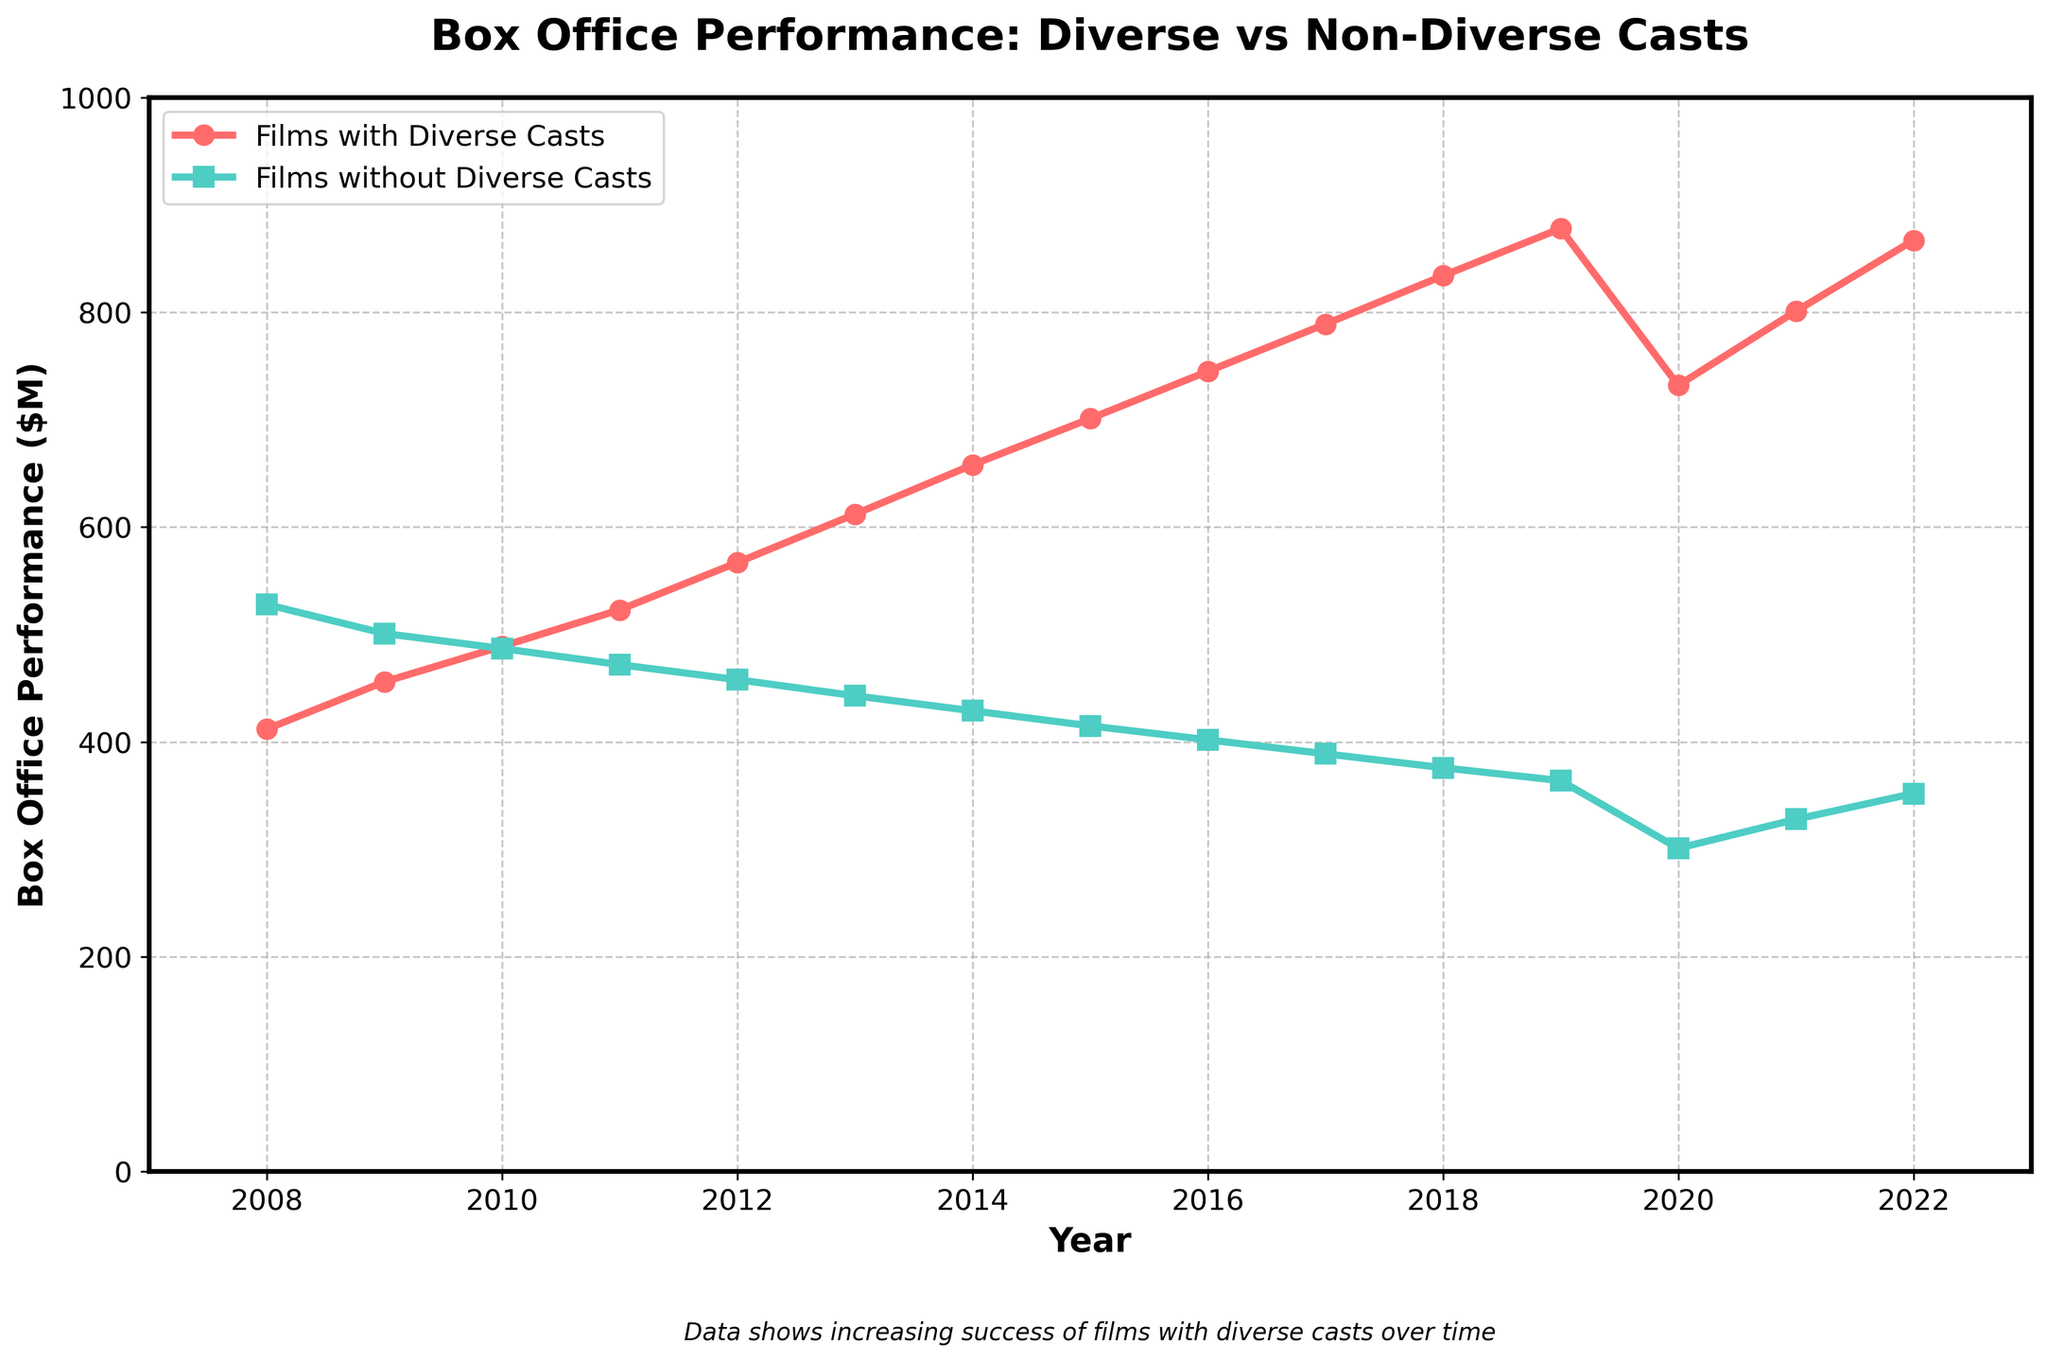What is the overall trend in box office performance for films with diverse casts over the last 15 years? The trend for films with diverse casts is consistently upward from 2008 to 2022, indicating an increase in box office performance each year.
Answer: Increasing How does the box office performance of films without diverse casts in 2019 compare to that in 2010? In 2010, the performance of films without diverse casts was $487 million, while in 2019, it was $364 million. This shows a decline over the years.
Answer: Declined Which year saw the highest box office performance for films with diverse casts? By examining the highest point of the red line, the year 2019 shows the highest box office performance at $878 million.
Answer: 2019 Calculate the average box office performance of films with diverse casts from 2010 to 2015. To find the average, sum the values from 2010 to 2015 and divide by the number of years: (489 + 523 + 567 + 612 + 658 + 701) / 6 = 550 million.
Answer: 550 million Between 2018 and 2020, which category of films (diverse or non-diverse casts) saw a greater drop in box office performance? Films with diverse casts dropped from $834 million in 2018 to $732 million in 2020, a decrease of 102 million. Films without diverse casts dropped from $376 million in 2018 to $301 million in 2020, a decrease of 75 million. Therefore, films with diverse casts saw a greater drop.
Answer: Diverse casts In what year do films with diverse casts first outperform films without diverse casts in terms of box office performance? Comparing the lines, films with diverse casts first outperform films without diverse casts in 2010.
Answer: 2010 What is the difference in box office performance between films with diverse casts and those without in 2021? Films with diverse casts earned $801 million, and those without earned $328 million in 2021. The difference is $801 million - $328 million = $473 million.
Answer: 473 million From 2009 to 2011, what is the percentage change in box office performance for films with diverse casts? The performance in 2009 was $456 million and in 2011 it was $523 million. The percentage change is [(523 - 456) / 456] * 100 = 14.69%.
Answer: 14.69% Calculate the median box office performance for films with diverse casts from 2008 to 2022. The ordered values are: 412, 456, 489, 523, 567, 612, 658, 701, 732, 745, 789, 801, 834, 867, 878. The median is the middle value, which is $701 million for the 8th position.
Answer: 701 million What is the visual difference in colors used to represent films with diverse casts and those without in the plot? Films with diverse casts are represented by red lines while those without diverse casts are represented by green lines.
Answer: Red and green 